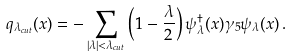Convert formula to latex. <formula><loc_0><loc_0><loc_500><loc_500>q _ { \lambda _ { c u t } } ( x ) = - \sum _ { | \lambda | < \lambda _ { c u t } } \left ( 1 - \frac { \lambda } { 2 } \right ) \psi _ { \lambda } ^ { \dagger } ( x ) \gamma _ { 5 } \psi _ { \lambda } ( x ) \, .</formula> 